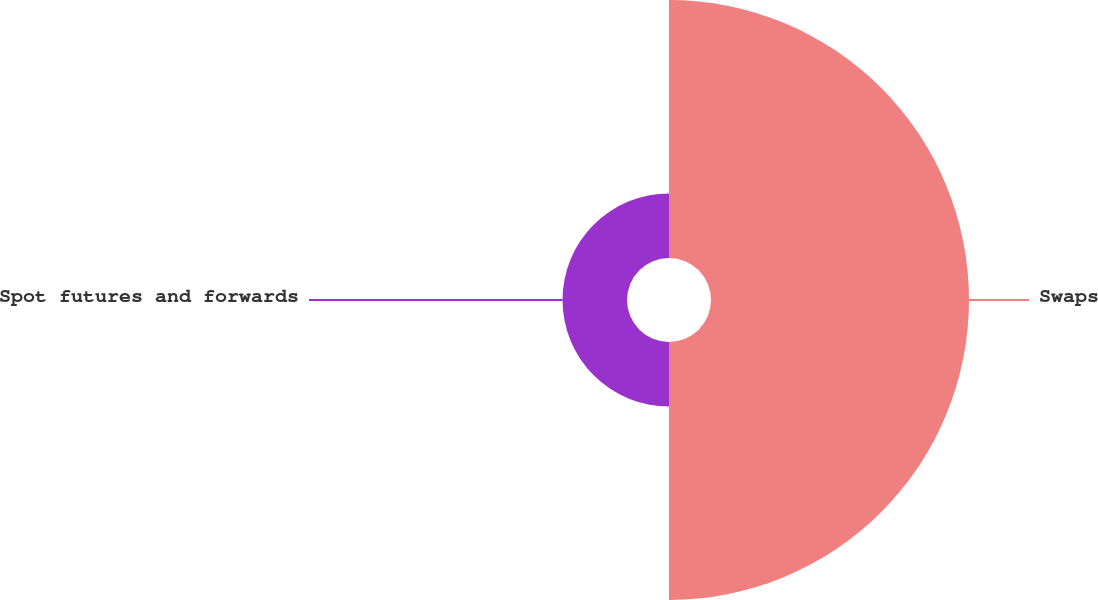<chart> <loc_0><loc_0><loc_500><loc_500><pie_chart><fcel>Swaps<fcel>Spot futures and forwards<nl><fcel>80.0%<fcel>20.0%<nl></chart> 